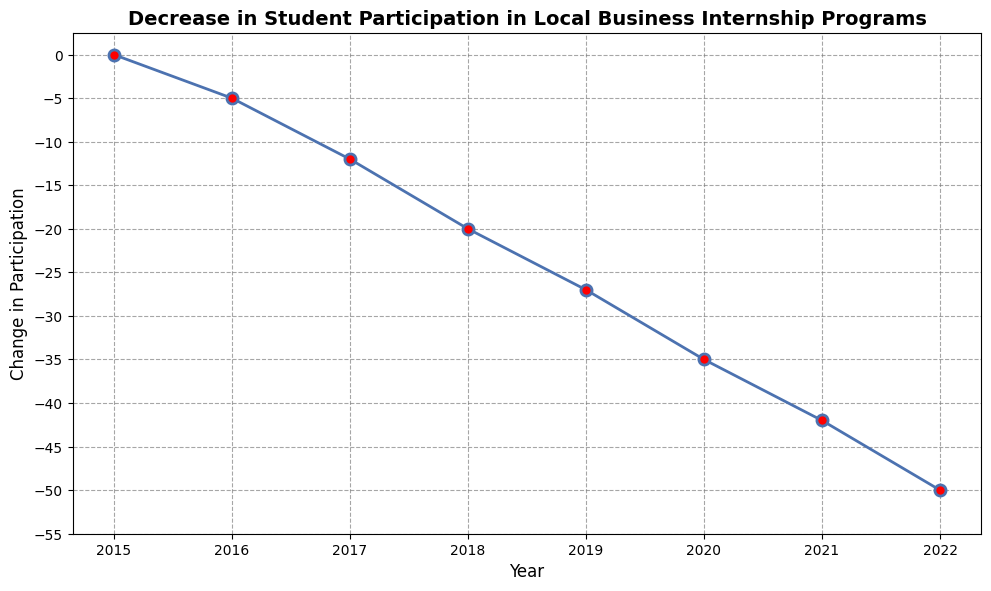What is the general trend in student participation in local business internship programs from 2015 to 2022? The line chart shows a downward trend in the change of student participation each year from 2015 to 2022, indicating a continuous decrease.
Answer: Decreasing Between which two consecutive years was the largest decrease in student participation observed? We need to compare the change in participation between consecutive years. The largest drop is between 2021 (-42) and 2022 (-50), which is a decrease of 8 units.
Answer: 2021 and 2022 What is the numerical change in student participation from 2015 to 2022? Subtract the 2022 value (-50) from the 2015 value (0). The change is \(0 - (-50) = -50\).
Answer: -50 Was there any year where student participation did not decrease? According to the chart, the participation did not decrease in 2015; that year it was 0.
Answer: 2015 What was the change in student participation in the year 2019? Referring to the plot at the year 2019 point, the value is -27.
Answer: -27 Calculate the average yearly change in student participation from 2015 to 2022. Summing the yearly changes: \(0 + (-5) + (-12) + (-20) + (-27) + (-35) + (-42) + (-50) = -191\). There are 8 years from 2015 to 2022. So, the average is \(-191 / 8 = -23.875\).
Answer: -23.875 How does student participation in 2016 compare to 2020? The participation change in 2016 is -5, and in 2020 it is -35. Comparing these, -35 is more negative than -5, indicating a greater decrease in 2020 compared to 2016.
Answer: Decreased more in 2020 If you were to highlight the point with the greatest drop in student participation on this line chart, which year would that be? To find the greatest drop, look for the highest negative difference between years. The most significant drop is 8 units, from 2021 to 2022. The year marking this drop would be 2022.
Answer: 2022 